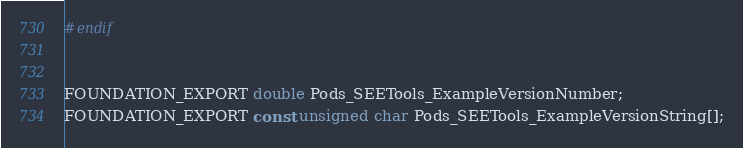Convert code to text. <code><loc_0><loc_0><loc_500><loc_500><_C_>#endif


FOUNDATION_EXPORT double Pods_SEETools_ExampleVersionNumber;
FOUNDATION_EXPORT const unsigned char Pods_SEETools_ExampleVersionString[];

</code> 